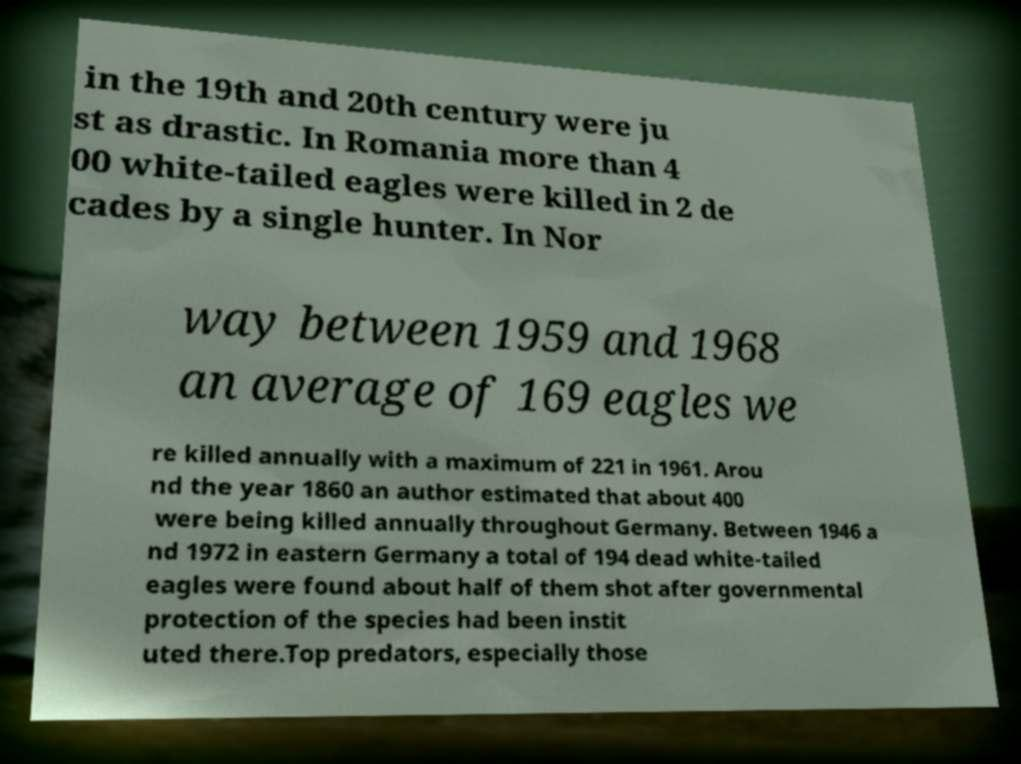Could you assist in decoding the text presented in this image and type it out clearly? in the 19th and 20th century were ju st as drastic. In Romania more than 4 00 white-tailed eagles were killed in 2 de cades by a single hunter. In Nor way between 1959 and 1968 an average of 169 eagles we re killed annually with a maximum of 221 in 1961. Arou nd the year 1860 an author estimated that about 400 were being killed annually throughout Germany. Between 1946 a nd 1972 in eastern Germany a total of 194 dead white-tailed eagles were found about half of them shot after governmental protection of the species had been instit uted there.Top predators, especially those 